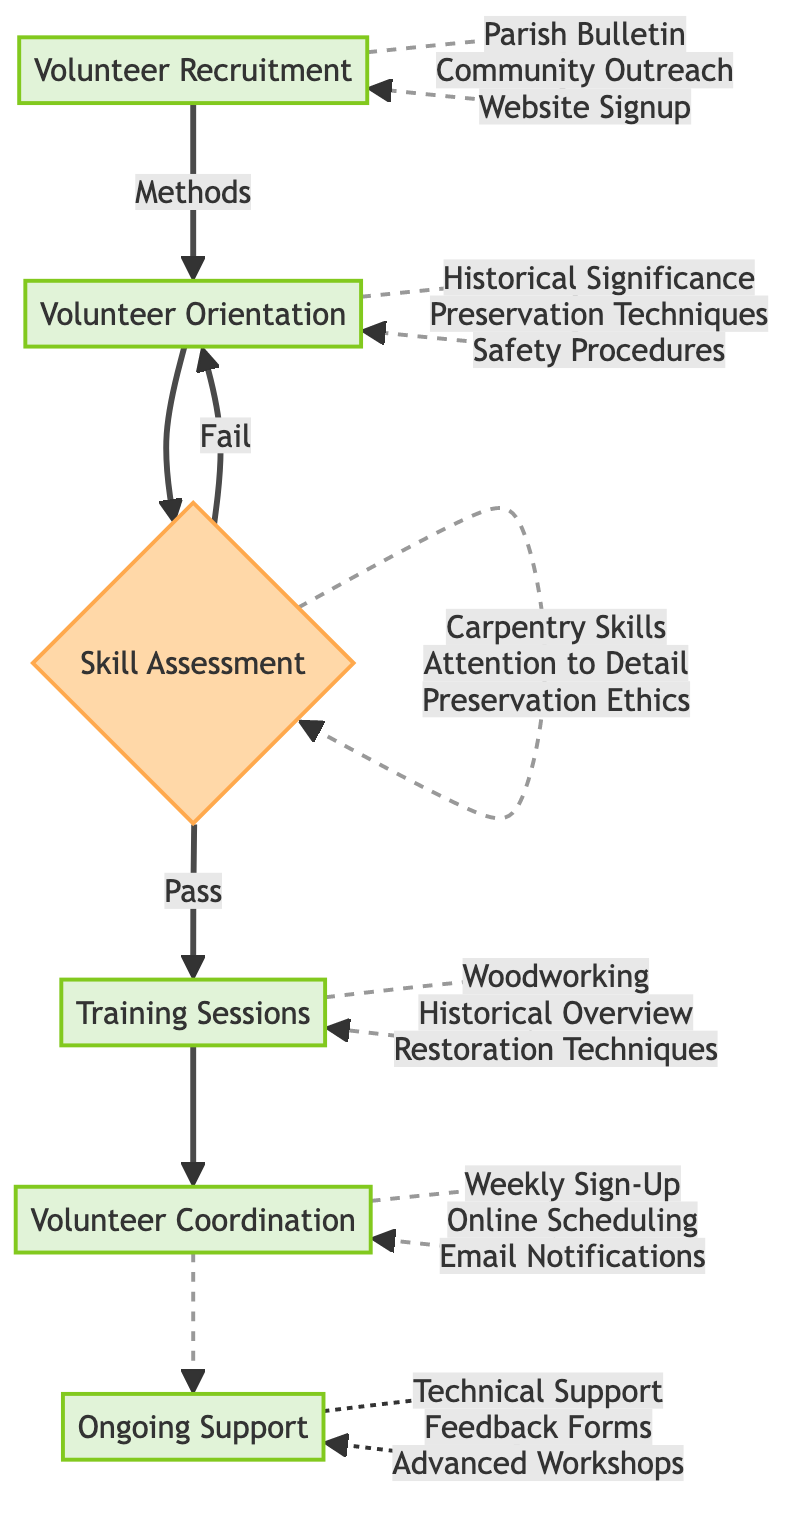What are the methods for volunteer recruitment? The diagram specifies three methods for volunteer recruitment: Parish Bulletin Announcements, Community Outreach Programs, and Church Website Volunteer Signup Form. These methods are listed directly under the Volunteer Recruitment node.
Answer: Parish Bulletin Announcements, Community Outreach Programs, Church Website Volunteer Signup Form Who conducts the volunteer orientation? The trainers listed in the diagram responsible for conducting the volunteer orientation are Historical Preservationist Dr. Laura Brown and Master Carpenter Carl Johnson. These names are stated under the Volunteer Orientation section.
Answer: Dr. Laura Brown, Carl Johnson What happens after the Skill Assessment if a volunteer passes? If a volunteer passes the Skill Assessment, the next step is the Training Sessions node. This is indicated by the “Pass” path leading from Skill Assessment to Training Sessions.
Answer: Training Sessions How many modules are included in the Training Sessions? The diagram outlines three specific modules included in the Training Sessions: Introduction to Woodworking, Historical Overview of Church Pews, and Restoration Techniques. A count of these modules reveals that there are three.
Answer: 3 Which volunteer coordination method involves scheduling? The method for volunteer coordination that involves scheduling is specified as "Weekly Sign-Up Sheets" and "Online Scheduling System." These methods are under the Volunteer Coordination node, indicating their relevance to scheduling volunteer activities.
Answer: Weekly Sign-Up Sheets, Online Scheduling System What are the two key components of Ongoing Support? The diagram indicates that two important components of Ongoing Support are Resources Available and Feedback Mechanisms. These categories are explicitly noted under the Ongoing Support node.
Answer: Resources Available, Feedback Mechanisms How do volunteers fail the Skill Assessment? Volunteers fail the Skill Assessment if they do not meet the established criteria listed in the diagram. The failure leads the flow back to the Volunteer Orientation node, indicating they may need to retake or continue training.
Answer: Returning to Volunteer Orientation Who oversees the volunteer coordination? The supervisors for volunteer coordination stated in the diagram are Project Manager James Wilson and Senior Volunteer Sarah Hamilton. Their roles are noted directly under the Volunteer Coordination section.
Answer: James Wilson, Sarah Hamilton What type of support can volunteers access ongoing? Volunteers can access a Technical Support Hotline as a form of ongoing support, among other resources. This is directly mentioned in the Ongoing Support section of the diagram.
Answer: Technical Support Hotline 